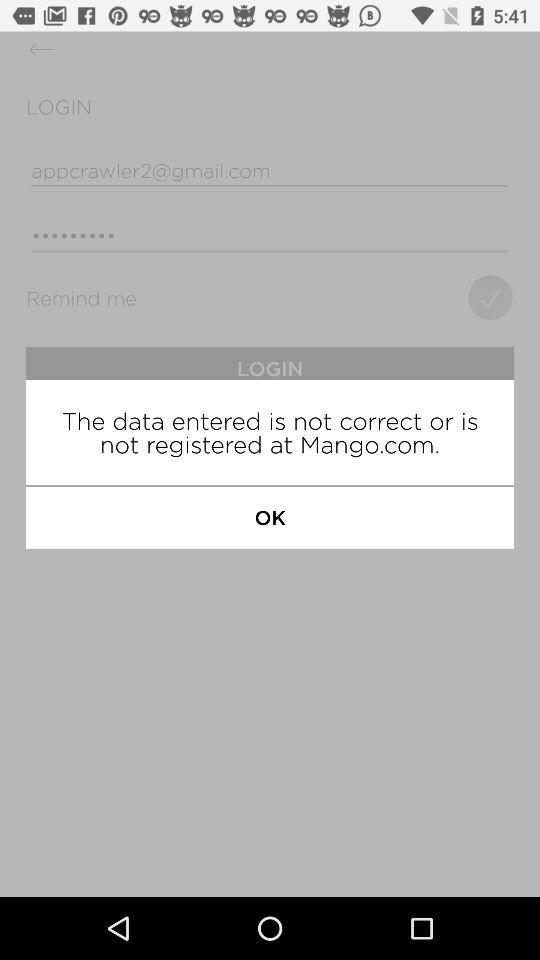What is the name of application?
When the provided information is insufficient, respond with <no answer>. <no answer> 